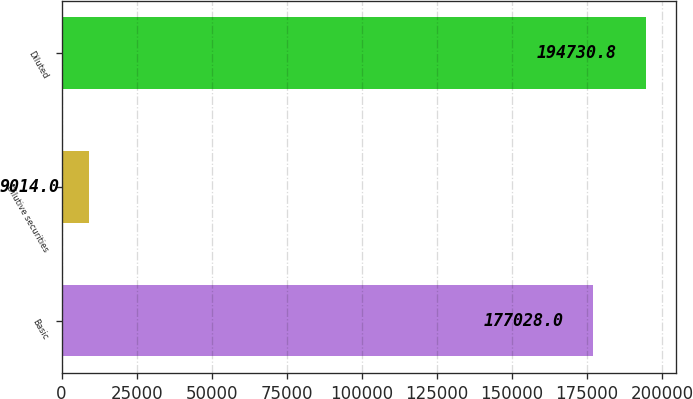Convert chart to OTSL. <chart><loc_0><loc_0><loc_500><loc_500><bar_chart><fcel>Basic<fcel>Dilutive securities<fcel>Diluted<nl><fcel>177028<fcel>9014<fcel>194731<nl></chart> 